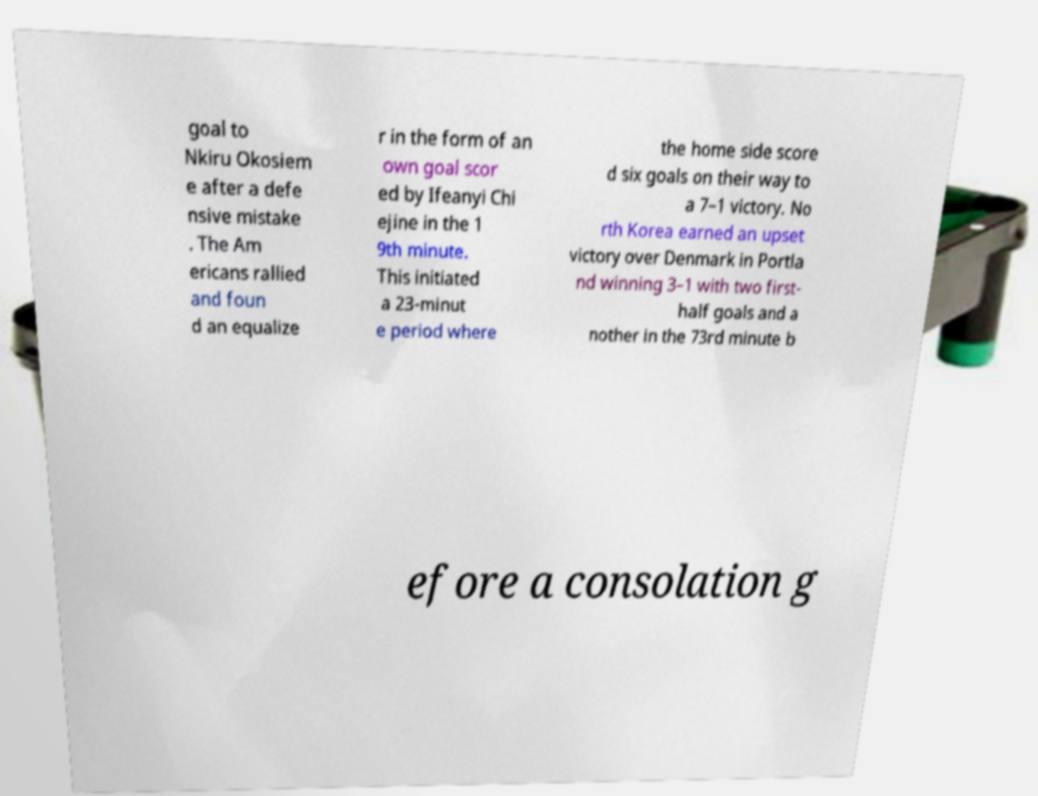For documentation purposes, I need the text within this image transcribed. Could you provide that? goal to Nkiru Okosiem e after a defe nsive mistake . The Am ericans rallied and foun d an equalize r in the form of an own goal scor ed by Ifeanyi Chi ejine in the 1 9th minute. This initiated a 23-minut e period where the home side score d six goals on their way to a 7–1 victory. No rth Korea earned an upset victory over Denmark in Portla nd winning 3–1 with two first- half goals and a nother in the 73rd minute b efore a consolation g 